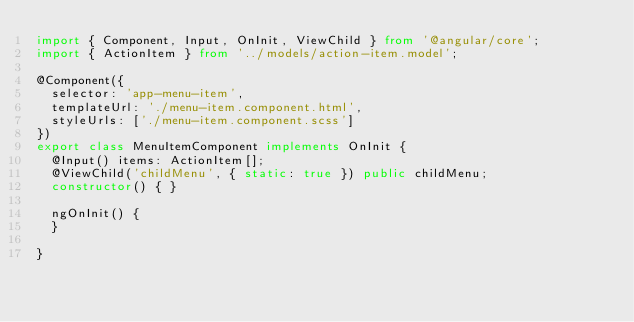<code> <loc_0><loc_0><loc_500><loc_500><_TypeScript_>import { Component, Input, OnInit, ViewChild } from '@angular/core';
import { ActionItem } from '../models/action-item.model';

@Component({
  selector: 'app-menu-item',
  templateUrl: './menu-item.component.html',
  styleUrls: ['./menu-item.component.scss']
})
export class MenuItemComponent implements OnInit {
  @Input() items: ActionItem[];
  @ViewChild('childMenu', { static: true }) public childMenu;
  constructor() { }

  ngOnInit() {
  }

}
</code> 